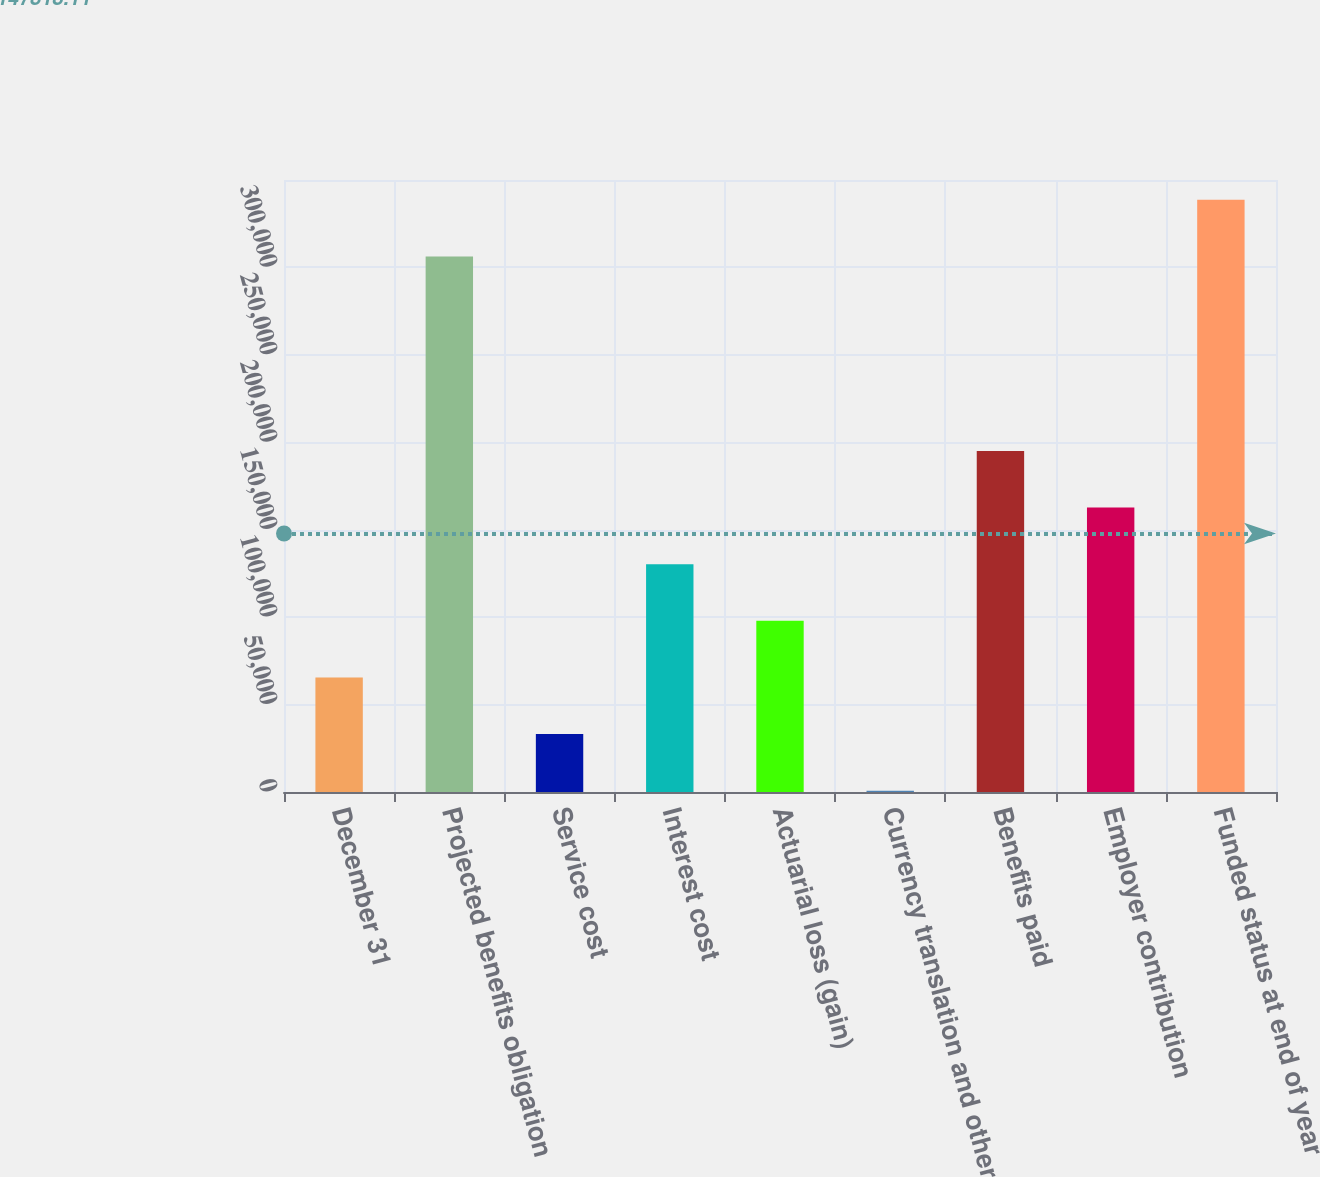<chart> <loc_0><loc_0><loc_500><loc_500><bar_chart><fcel>December 31<fcel>Projected benefits obligation<fcel>Service cost<fcel>Interest cost<fcel>Actuarial loss (gain)<fcel>Currency translation and other<fcel>Benefits paid<fcel>Employer contribution<fcel>Funded status at end of year<nl><fcel>65525<fcel>306300<fcel>33139<fcel>130297<fcel>97911<fcel>753<fcel>195069<fcel>162683<fcel>338686<nl></chart> 